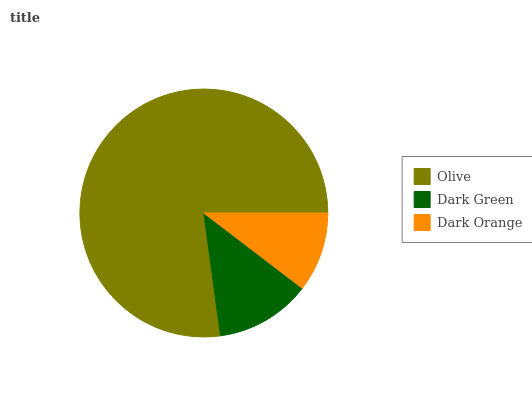Is Dark Orange the minimum?
Answer yes or no. Yes. Is Olive the maximum?
Answer yes or no. Yes. Is Dark Green the minimum?
Answer yes or no. No. Is Dark Green the maximum?
Answer yes or no. No. Is Olive greater than Dark Green?
Answer yes or no. Yes. Is Dark Green less than Olive?
Answer yes or no. Yes. Is Dark Green greater than Olive?
Answer yes or no. No. Is Olive less than Dark Green?
Answer yes or no. No. Is Dark Green the high median?
Answer yes or no. Yes. Is Dark Green the low median?
Answer yes or no. Yes. Is Olive the high median?
Answer yes or no. No. Is Dark Orange the low median?
Answer yes or no. No. 